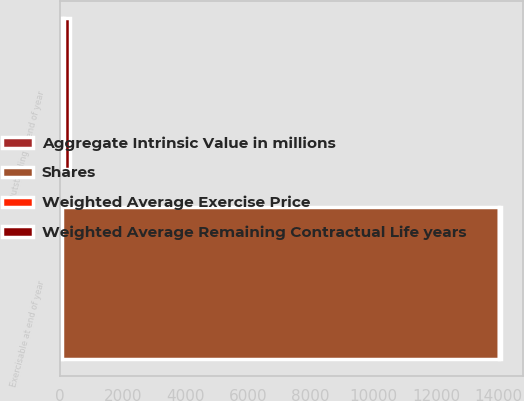Convert chart to OTSL. <chart><loc_0><loc_0><loc_500><loc_500><stacked_bar_chart><ecel><fcel>Outstanding at end of year<fcel>Exercisable at end of year<nl><fcel>Shares<fcel>63.93<fcel>13940<nl><fcel>Aggregate Intrinsic Value in millions<fcel>63.93<fcel>70.33<nl><fcel>Weighted Average Exercise Price<fcel>7.09<fcel>5.61<nl><fcel>Weighted Average Remaining Contractual Life years<fcel>179<fcel>47<nl></chart> 